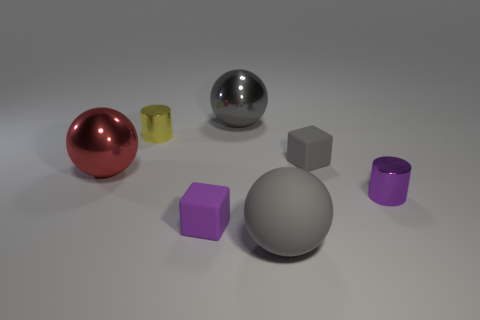What number of things are tiny gray rubber cubes or cyan cubes?
Ensure brevity in your answer.  1. Does the purple shiny cylinder have the same size as the gray cube right of the tiny yellow metallic cylinder?
Offer a very short reply. Yes. There is a cylinder that is right of the tiny gray object behind the big gray thing in front of the red shiny thing; what size is it?
Your answer should be very brief. Small. Is there a red ball?
Make the answer very short. Yes. There is a tiny thing that is the same color as the big rubber ball; what material is it?
Ensure brevity in your answer.  Rubber. How many rubber cubes have the same color as the large matte sphere?
Your answer should be very brief. 1. What number of things are either small matte cubes that are behind the purple cylinder or big balls behind the red ball?
Make the answer very short. 2. There is a large sphere behind the gray cube; how many large red things are on the right side of it?
Offer a very short reply. 0. There is another tiny thing that is made of the same material as the yellow thing; what is its color?
Keep it short and to the point. Purple. Is there a gray matte block that has the same size as the red object?
Ensure brevity in your answer.  No. 